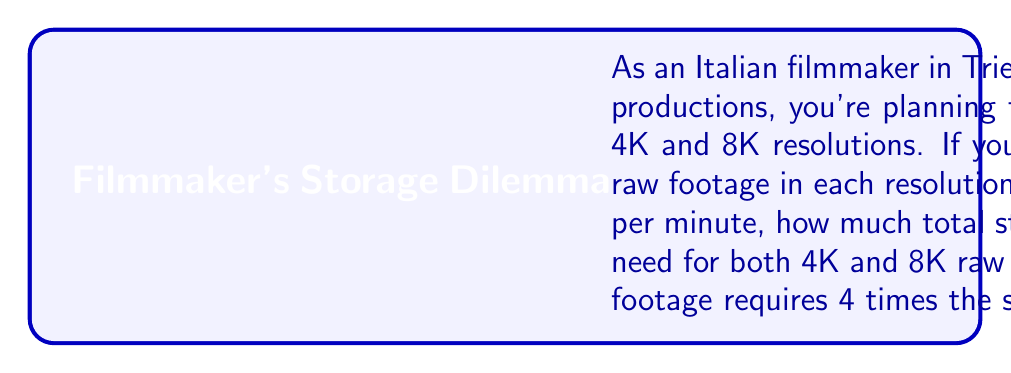Solve this math problem. Let's approach this problem step by step:

1. Calculate the storage needed for 4K footage:
   - 4K footage requires 7 GB per minute
   - Convert 100 hours to minutes: $100 \text{ hours} \times 60 \text{ min/hour} = 6000 \text{ minutes}$
   - Storage for 4K: $6000 \text{ minutes} \times 7 \text{ GB/minute} = 42000 \text{ GB}$

2. Calculate the storage needed for 8K footage:
   - 8K footage requires 4 times the storage of 4K
   - Storage for 8K: $42000 \text{ GB} \times 4 = 168000 \text{ GB}$

3. Calculate the total storage needed:
   - Total storage: $42000 \text{ GB} + 168000 \text{ GB} = 210000 \text{ GB}$

4. Convert the total storage from GB to TB:
   - 1 TB = 1000 GB
   - Total storage in TB: $210000 \text{ GB} \div 1000 \text{ GB/TB} = 210 \text{ TB}$

Therefore, the total storage capacity needed for both 4K and 8K raw footage combined is 210 TB.
Answer: 210 TB 